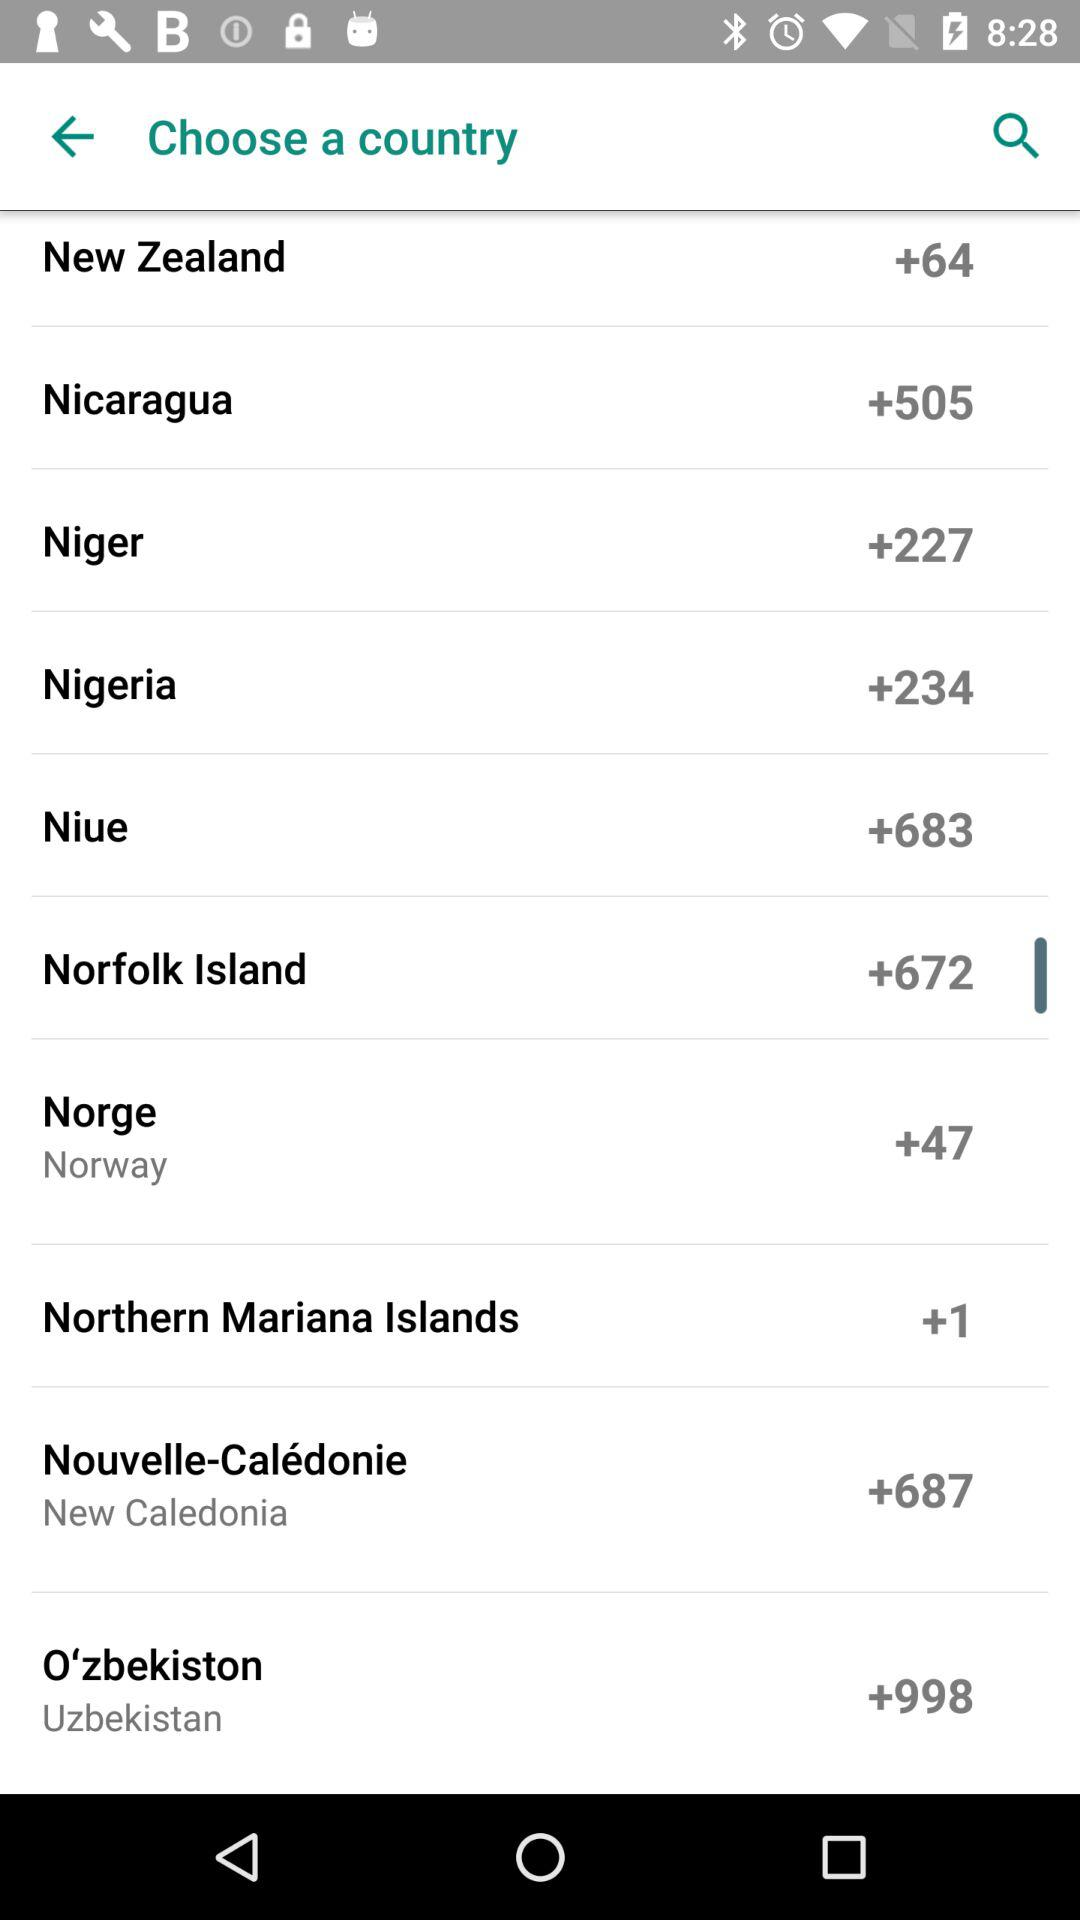How many likes does the application have?
When the provided information is insufficient, respond with <no answer>. <no answer> 